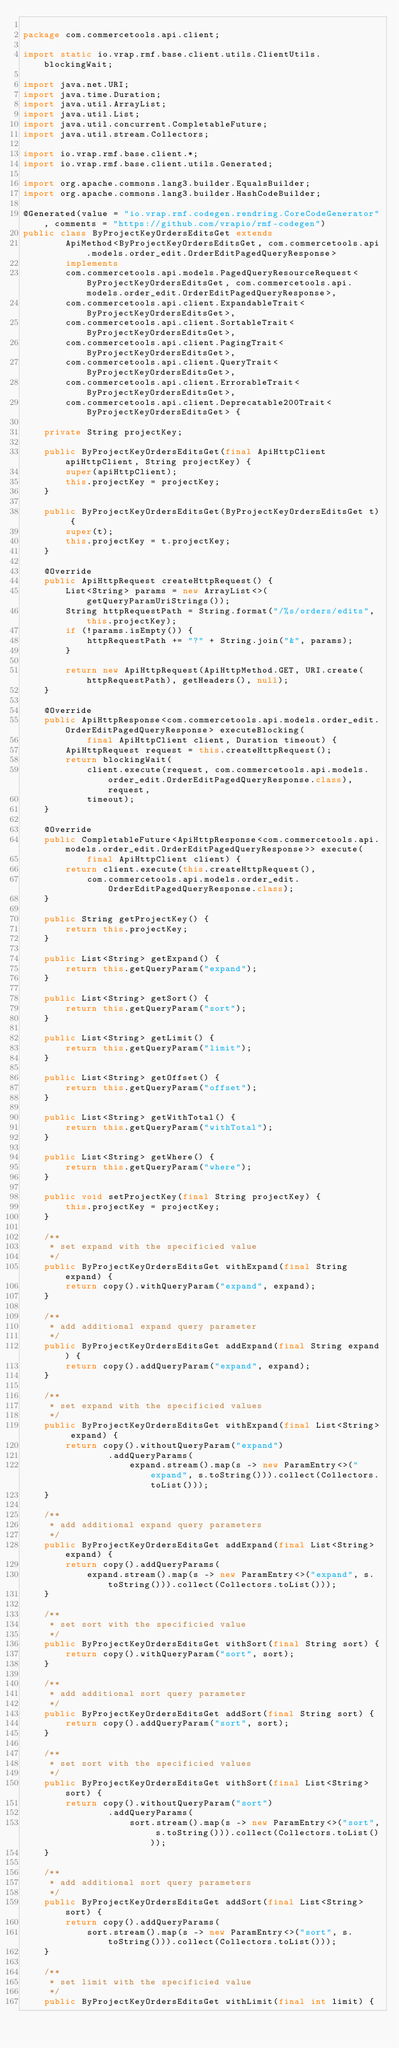Convert code to text. <code><loc_0><loc_0><loc_500><loc_500><_Java_>
package com.commercetools.api.client;

import static io.vrap.rmf.base.client.utils.ClientUtils.blockingWait;

import java.net.URI;
import java.time.Duration;
import java.util.ArrayList;
import java.util.List;
import java.util.concurrent.CompletableFuture;
import java.util.stream.Collectors;

import io.vrap.rmf.base.client.*;
import io.vrap.rmf.base.client.utils.Generated;

import org.apache.commons.lang3.builder.EqualsBuilder;
import org.apache.commons.lang3.builder.HashCodeBuilder;

@Generated(value = "io.vrap.rmf.codegen.rendring.CoreCodeGenerator", comments = "https://github.com/vrapio/rmf-codegen")
public class ByProjectKeyOrdersEditsGet extends
        ApiMethod<ByProjectKeyOrdersEditsGet, com.commercetools.api.models.order_edit.OrderEditPagedQueryResponse>
        implements
        com.commercetools.api.models.PagedQueryResourceRequest<ByProjectKeyOrdersEditsGet, com.commercetools.api.models.order_edit.OrderEditPagedQueryResponse>,
        com.commercetools.api.client.ExpandableTrait<ByProjectKeyOrdersEditsGet>,
        com.commercetools.api.client.SortableTrait<ByProjectKeyOrdersEditsGet>,
        com.commercetools.api.client.PagingTrait<ByProjectKeyOrdersEditsGet>,
        com.commercetools.api.client.QueryTrait<ByProjectKeyOrdersEditsGet>,
        com.commercetools.api.client.ErrorableTrait<ByProjectKeyOrdersEditsGet>,
        com.commercetools.api.client.Deprecatable200Trait<ByProjectKeyOrdersEditsGet> {

    private String projectKey;

    public ByProjectKeyOrdersEditsGet(final ApiHttpClient apiHttpClient, String projectKey) {
        super(apiHttpClient);
        this.projectKey = projectKey;
    }

    public ByProjectKeyOrdersEditsGet(ByProjectKeyOrdersEditsGet t) {
        super(t);
        this.projectKey = t.projectKey;
    }

    @Override
    public ApiHttpRequest createHttpRequest() {
        List<String> params = new ArrayList<>(getQueryParamUriStrings());
        String httpRequestPath = String.format("/%s/orders/edits", this.projectKey);
        if (!params.isEmpty()) {
            httpRequestPath += "?" + String.join("&", params);
        }

        return new ApiHttpRequest(ApiHttpMethod.GET, URI.create(httpRequestPath), getHeaders(), null);
    }

    @Override
    public ApiHttpResponse<com.commercetools.api.models.order_edit.OrderEditPagedQueryResponse> executeBlocking(
            final ApiHttpClient client, Duration timeout) {
        ApiHttpRequest request = this.createHttpRequest();
        return blockingWait(
            client.execute(request, com.commercetools.api.models.order_edit.OrderEditPagedQueryResponse.class), request,
            timeout);
    }

    @Override
    public CompletableFuture<ApiHttpResponse<com.commercetools.api.models.order_edit.OrderEditPagedQueryResponse>> execute(
            final ApiHttpClient client) {
        return client.execute(this.createHttpRequest(),
            com.commercetools.api.models.order_edit.OrderEditPagedQueryResponse.class);
    }

    public String getProjectKey() {
        return this.projectKey;
    }

    public List<String> getExpand() {
        return this.getQueryParam("expand");
    }

    public List<String> getSort() {
        return this.getQueryParam("sort");
    }

    public List<String> getLimit() {
        return this.getQueryParam("limit");
    }

    public List<String> getOffset() {
        return this.getQueryParam("offset");
    }

    public List<String> getWithTotal() {
        return this.getQueryParam("withTotal");
    }

    public List<String> getWhere() {
        return this.getQueryParam("where");
    }

    public void setProjectKey(final String projectKey) {
        this.projectKey = projectKey;
    }

    /**
     * set expand with the specificied value
     */
    public ByProjectKeyOrdersEditsGet withExpand(final String expand) {
        return copy().withQueryParam("expand", expand);
    }

    /**
     * add additional expand query parameter
     */
    public ByProjectKeyOrdersEditsGet addExpand(final String expand) {
        return copy().addQueryParam("expand", expand);
    }

    /**
     * set expand with the specificied values
     */
    public ByProjectKeyOrdersEditsGet withExpand(final List<String> expand) {
        return copy().withoutQueryParam("expand")
                .addQueryParams(
                    expand.stream().map(s -> new ParamEntry<>("expand", s.toString())).collect(Collectors.toList()));
    }

    /**
     * add additional expand query parameters
     */
    public ByProjectKeyOrdersEditsGet addExpand(final List<String> expand) {
        return copy().addQueryParams(
            expand.stream().map(s -> new ParamEntry<>("expand", s.toString())).collect(Collectors.toList()));
    }

    /**
     * set sort with the specificied value
     */
    public ByProjectKeyOrdersEditsGet withSort(final String sort) {
        return copy().withQueryParam("sort", sort);
    }

    /**
     * add additional sort query parameter
     */
    public ByProjectKeyOrdersEditsGet addSort(final String sort) {
        return copy().addQueryParam("sort", sort);
    }

    /**
     * set sort with the specificied values
     */
    public ByProjectKeyOrdersEditsGet withSort(final List<String> sort) {
        return copy().withoutQueryParam("sort")
                .addQueryParams(
                    sort.stream().map(s -> new ParamEntry<>("sort", s.toString())).collect(Collectors.toList()));
    }

    /**
     * add additional sort query parameters
     */
    public ByProjectKeyOrdersEditsGet addSort(final List<String> sort) {
        return copy().addQueryParams(
            sort.stream().map(s -> new ParamEntry<>("sort", s.toString())).collect(Collectors.toList()));
    }

    /**
     * set limit with the specificied value
     */
    public ByProjectKeyOrdersEditsGet withLimit(final int limit) {</code> 